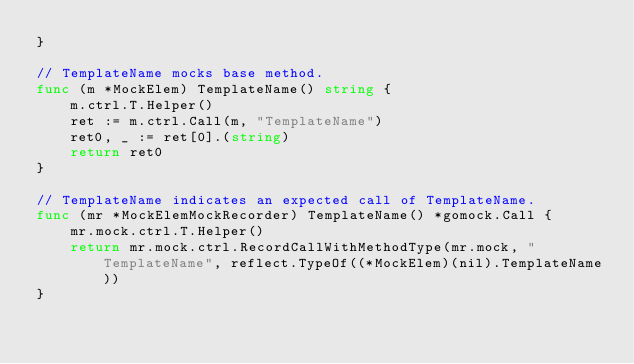Convert code to text. <code><loc_0><loc_0><loc_500><loc_500><_Go_>}

// TemplateName mocks base method.
func (m *MockElem) TemplateName() string {
	m.ctrl.T.Helper()
	ret := m.ctrl.Call(m, "TemplateName")
	ret0, _ := ret[0].(string)
	return ret0
}

// TemplateName indicates an expected call of TemplateName.
func (mr *MockElemMockRecorder) TemplateName() *gomock.Call {
	mr.mock.ctrl.T.Helper()
	return mr.mock.ctrl.RecordCallWithMethodType(mr.mock, "TemplateName", reflect.TypeOf((*MockElem)(nil).TemplateName))
}
</code> 